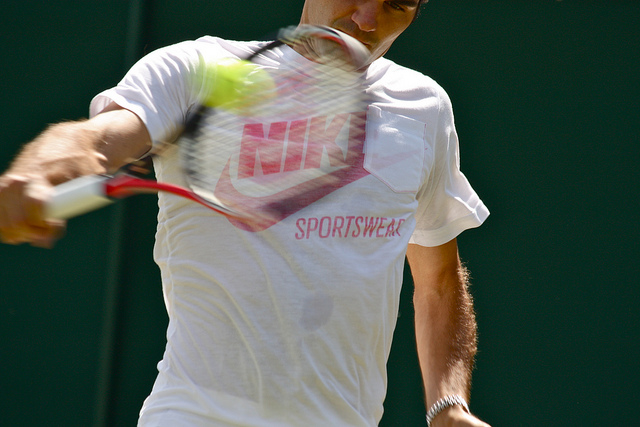<image>What famous athlete is playing tennis in the photo? I don't know which famous athlete is playing tennis in the photo. It could be Beckham, Federer, Manning, William, Andrea or Nadal. What famous athlete is playing tennis in the photo? It is not clear which famous athlete is playing tennis in the photo. It could be Beckham, Federer, or Nadal. 